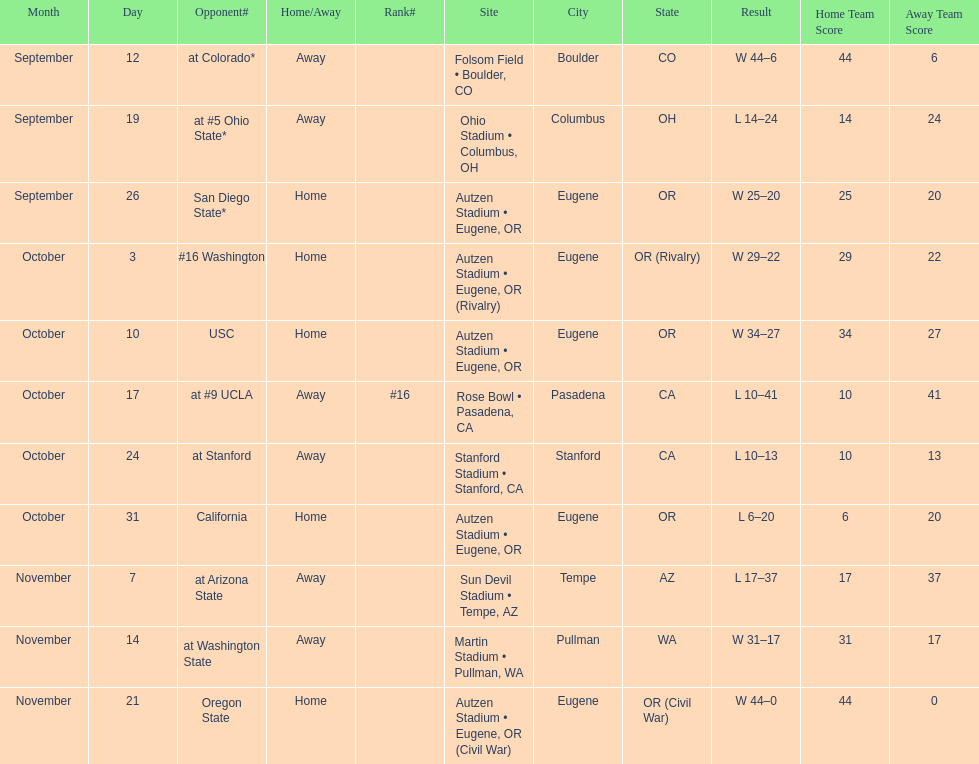Did the team win or lose more games? Win. 